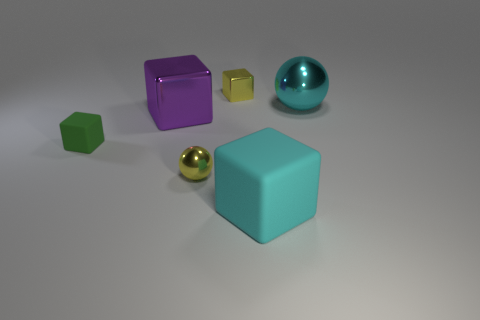There is a large purple cube in front of the large cyan thing that is behind the tiny rubber cube; is there a green rubber cube that is behind it?
Your answer should be compact. No. What number of rubber objects are either large objects or purple objects?
Make the answer very short. 1. How many other objects are there of the same shape as the green thing?
Your answer should be compact. 3. Are there more tiny cyan rubber blocks than tiny cubes?
Your answer should be compact. No. There is a matte thing that is in front of the matte block that is on the left side of the cyan object that is in front of the big cyan ball; how big is it?
Provide a short and direct response. Large. What is the size of the matte object on the right side of the small yellow shiny cube?
Offer a very short reply. Large. How many objects are large purple cubes or tiny yellow shiny things behind the large cyan shiny sphere?
Provide a short and direct response. 2. What number of other objects are there of the same size as the green cube?
Offer a terse response. 2. There is a yellow object that is the same shape as the small green matte thing; what material is it?
Offer a very short reply. Metal. Are there more yellow metal objects on the right side of the big cyan cube than brown balls?
Make the answer very short. No. 